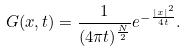<formula> <loc_0><loc_0><loc_500><loc_500>G ( x , t ) = \frac { 1 } { ( 4 \pi t ) ^ { \frac { N } { 2 } } } e ^ { - \frac { | x | ^ { 2 } } { 4 t } } .</formula> 